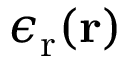Convert formula to latex. <formula><loc_0><loc_0><loc_500><loc_500>\epsilon _ { r } ( r )</formula> 